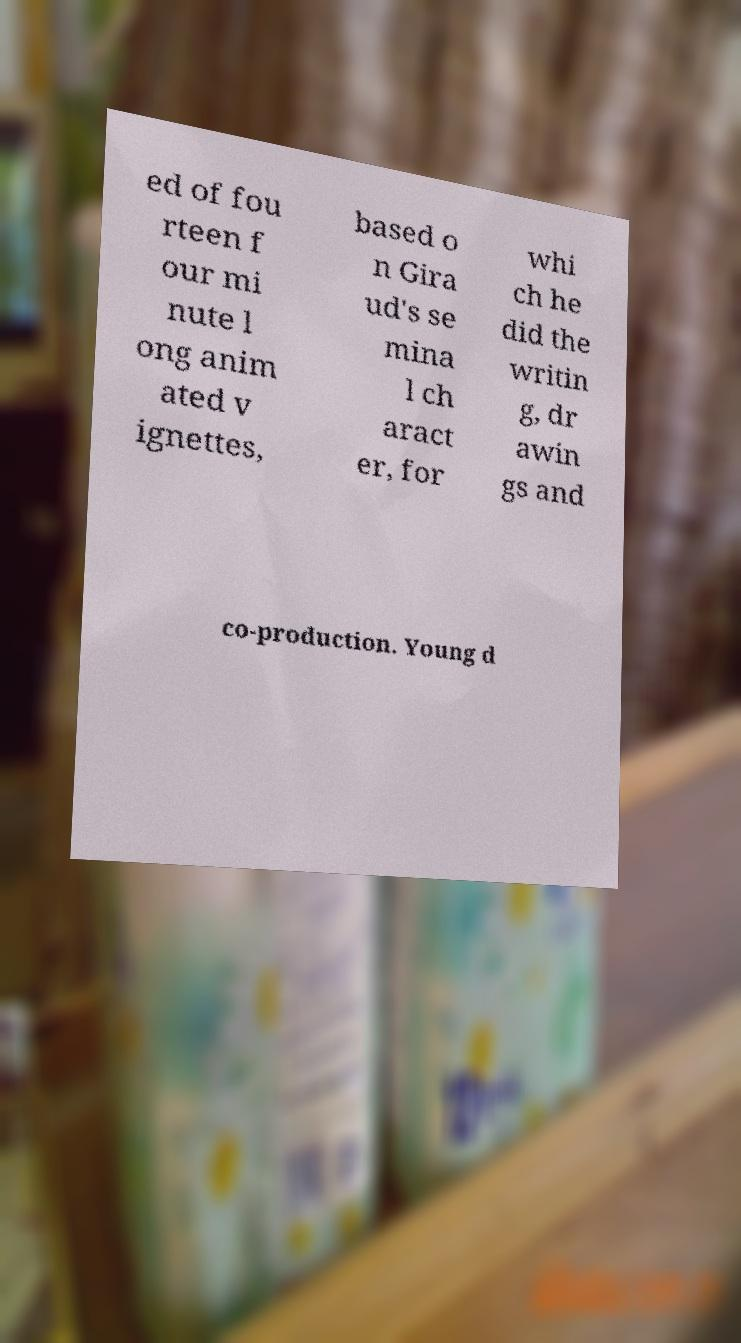Can you read and provide the text displayed in the image?This photo seems to have some interesting text. Can you extract and type it out for me? ed of fou rteen f our mi nute l ong anim ated v ignettes, based o n Gira ud's se mina l ch aract er, for whi ch he did the writin g, dr awin gs and co-production. Young d 